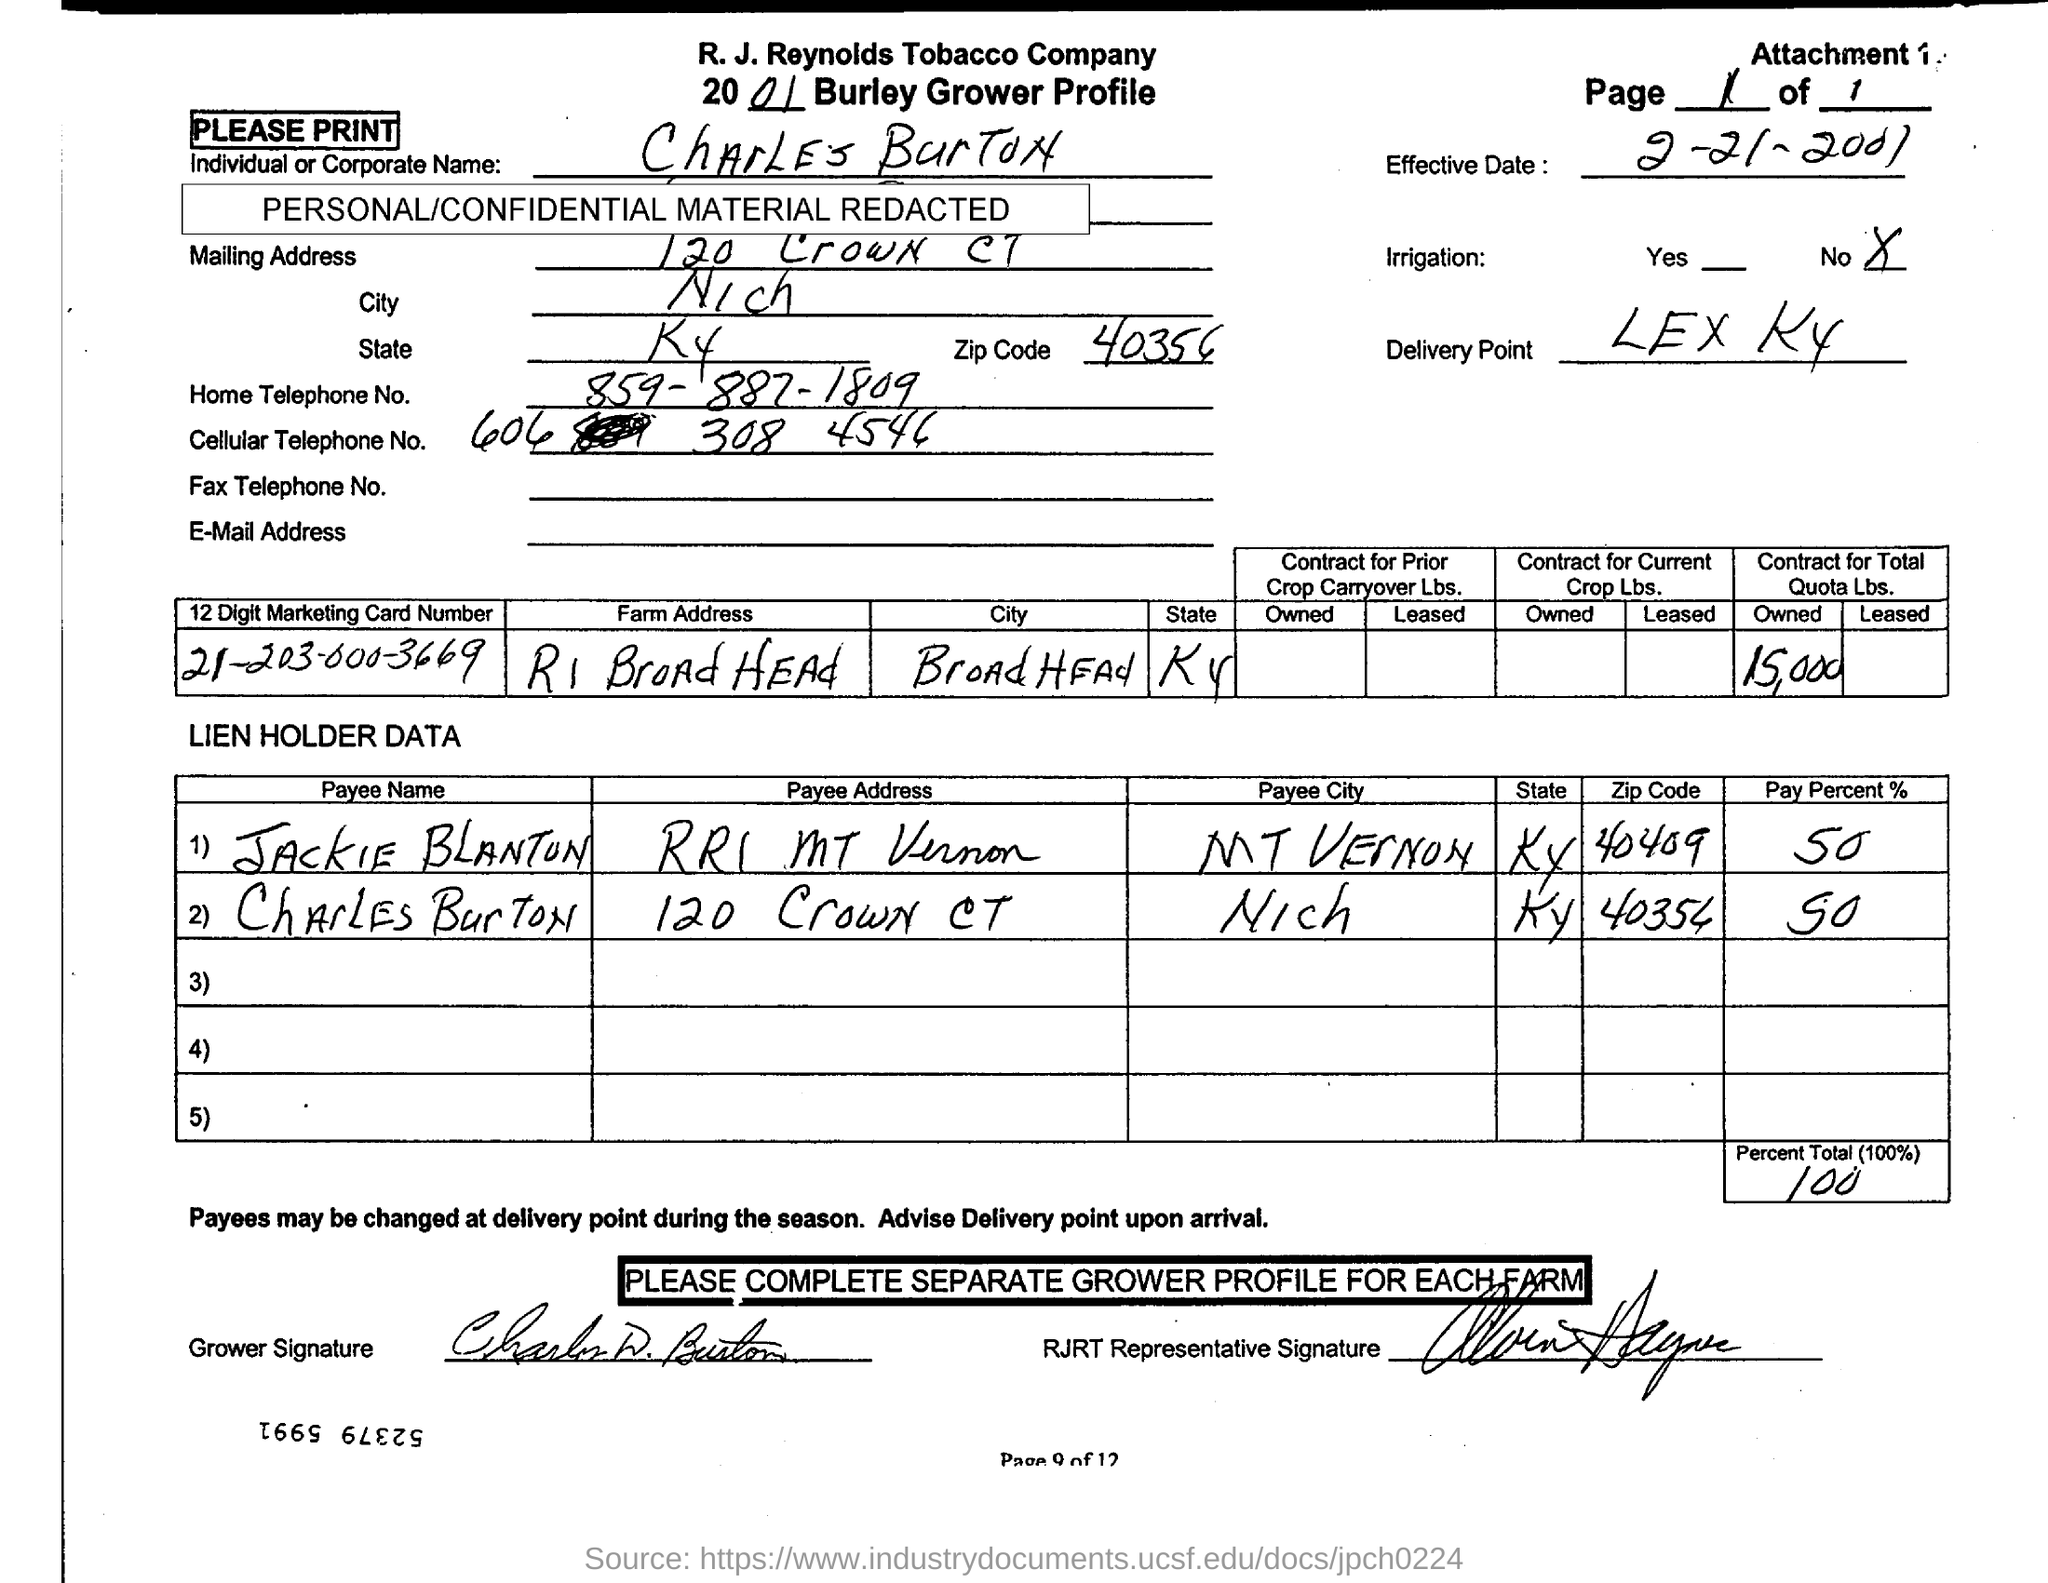Mention the owned Quota Lbs. contract in total? The document clearly shows that the total owned Quota Lbs. contract amount is listed as 15,000 pounds, under the 'Contract for Total Quota Lbs.' column. This figure represents the full contracted quantity for the crop in question. 